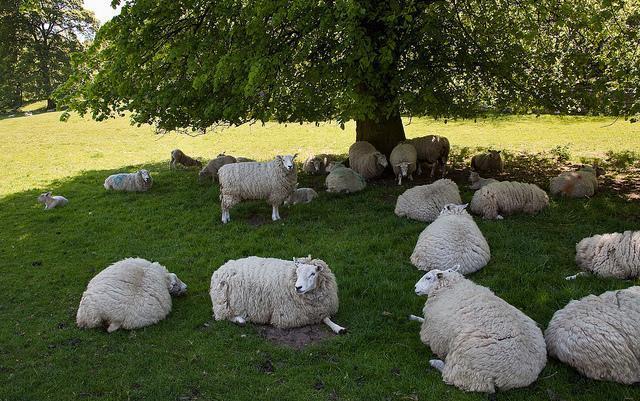How many sheep are in the photo?
Give a very brief answer. 9. How many people are wearing a hat in the image?
Give a very brief answer. 0. 